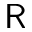<formula> <loc_0><loc_0><loc_500><loc_500>R</formula> 